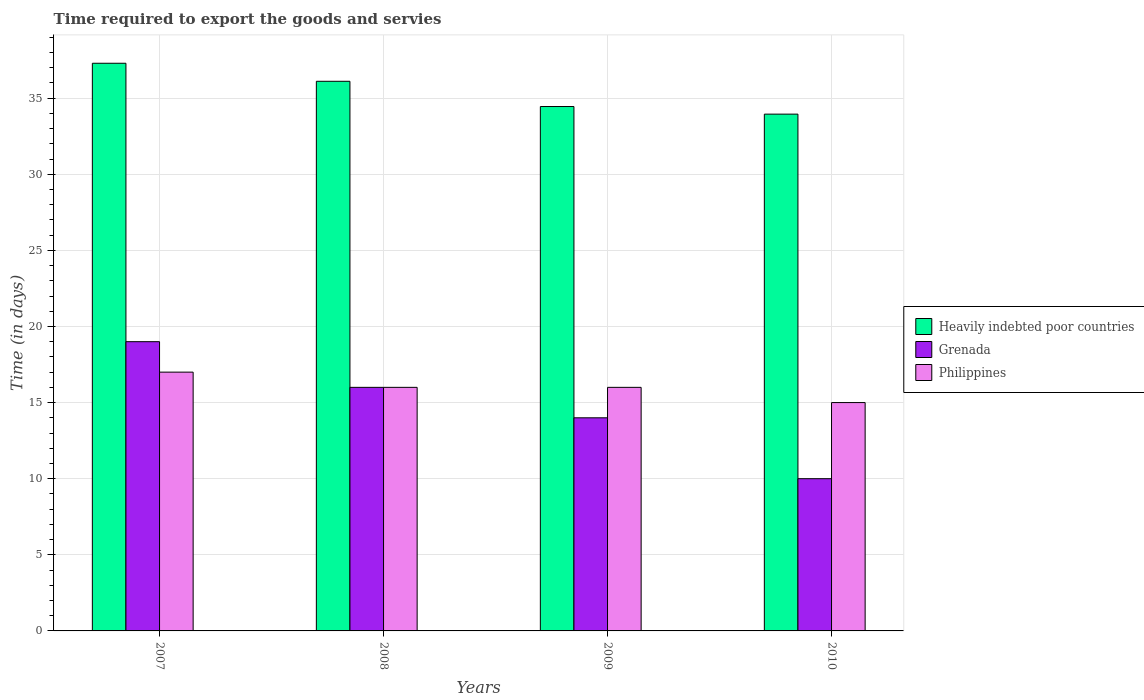Are the number of bars per tick equal to the number of legend labels?
Your answer should be very brief. Yes. Are the number of bars on each tick of the X-axis equal?
Offer a terse response. Yes. How many bars are there on the 3rd tick from the left?
Make the answer very short. 3. How many bars are there on the 1st tick from the right?
Your response must be concise. 3. What is the number of days required to export the goods and services in Grenada in 2009?
Your response must be concise. 14. Across all years, what is the maximum number of days required to export the goods and services in Heavily indebted poor countries?
Keep it short and to the point. 37.29. Across all years, what is the minimum number of days required to export the goods and services in Grenada?
Your answer should be very brief. 10. In which year was the number of days required to export the goods and services in Philippines maximum?
Ensure brevity in your answer.  2007. In which year was the number of days required to export the goods and services in Heavily indebted poor countries minimum?
Ensure brevity in your answer.  2010. What is the total number of days required to export the goods and services in Heavily indebted poor countries in the graph?
Ensure brevity in your answer.  141.79. What is the difference between the number of days required to export the goods and services in Grenada in 2009 and that in 2010?
Your answer should be very brief. 4. What is the difference between the number of days required to export the goods and services in Philippines in 2008 and the number of days required to export the goods and services in Heavily indebted poor countries in 2010?
Your response must be concise. -17.95. What is the average number of days required to export the goods and services in Heavily indebted poor countries per year?
Offer a terse response. 35.45. In the year 2010, what is the difference between the number of days required to export the goods and services in Grenada and number of days required to export the goods and services in Heavily indebted poor countries?
Your answer should be compact. -23.95. In how many years, is the number of days required to export the goods and services in Grenada greater than 10 days?
Provide a succinct answer. 3. Is the number of days required to export the goods and services in Philippines in 2007 less than that in 2009?
Offer a very short reply. No. What is the difference between the highest and the second highest number of days required to export the goods and services in Heavily indebted poor countries?
Provide a short and direct response. 1.18. What is the difference between the highest and the lowest number of days required to export the goods and services in Heavily indebted poor countries?
Make the answer very short. 3.34. In how many years, is the number of days required to export the goods and services in Grenada greater than the average number of days required to export the goods and services in Grenada taken over all years?
Offer a very short reply. 2. What does the 3rd bar from the left in 2007 represents?
Your response must be concise. Philippines. What does the 1st bar from the right in 2007 represents?
Ensure brevity in your answer.  Philippines. Are all the bars in the graph horizontal?
Give a very brief answer. No. How many years are there in the graph?
Provide a short and direct response. 4. What is the difference between two consecutive major ticks on the Y-axis?
Give a very brief answer. 5. Are the values on the major ticks of Y-axis written in scientific E-notation?
Your answer should be compact. No. Does the graph contain any zero values?
Offer a terse response. No. Where does the legend appear in the graph?
Your response must be concise. Center right. How are the legend labels stacked?
Make the answer very short. Vertical. What is the title of the graph?
Give a very brief answer. Time required to export the goods and servies. Does "Palau" appear as one of the legend labels in the graph?
Offer a terse response. No. What is the label or title of the X-axis?
Your answer should be very brief. Years. What is the label or title of the Y-axis?
Your response must be concise. Time (in days). What is the Time (in days) in Heavily indebted poor countries in 2007?
Provide a succinct answer. 37.29. What is the Time (in days) of Philippines in 2007?
Give a very brief answer. 17. What is the Time (in days) of Heavily indebted poor countries in 2008?
Keep it short and to the point. 36.11. What is the Time (in days) of Philippines in 2008?
Keep it short and to the point. 16. What is the Time (in days) in Heavily indebted poor countries in 2009?
Make the answer very short. 34.45. What is the Time (in days) in Grenada in 2009?
Make the answer very short. 14. What is the Time (in days) of Philippines in 2009?
Give a very brief answer. 16. What is the Time (in days) in Heavily indebted poor countries in 2010?
Make the answer very short. 33.95. What is the Time (in days) of Grenada in 2010?
Give a very brief answer. 10. What is the Time (in days) in Philippines in 2010?
Your answer should be compact. 15. Across all years, what is the maximum Time (in days) in Heavily indebted poor countries?
Make the answer very short. 37.29. Across all years, what is the minimum Time (in days) of Heavily indebted poor countries?
Offer a very short reply. 33.95. Across all years, what is the minimum Time (in days) in Grenada?
Offer a very short reply. 10. What is the total Time (in days) in Heavily indebted poor countries in the graph?
Offer a terse response. 141.79. What is the total Time (in days) in Grenada in the graph?
Ensure brevity in your answer.  59. What is the total Time (in days) of Philippines in the graph?
Your response must be concise. 64. What is the difference between the Time (in days) in Heavily indebted poor countries in 2007 and that in 2008?
Make the answer very short. 1.18. What is the difference between the Time (in days) in Philippines in 2007 and that in 2008?
Your answer should be compact. 1. What is the difference between the Time (in days) of Heavily indebted poor countries in 2007 and that in 2009?
Provide a succinct answer. 2.84. What is the difference between the Time (in days) of Philippines in 2007 and that in 2009?
Offer a terse response. 1. What is the difference between the Time (in days) in Heavily indebted poor countries in 2007 and that in 2010?
Give a very brief answer. 3.34. What is the difference between the Time (in days) in Grenada in 2007 and that in 2010?
Make the answer very short. 9. What is the difference between the Time (in days) in Heavily indebted poor countries in 2008 and that in 2009?
Your response must be concise. 1.66. What is the difference between the Time (in days) of Grenada in 2008 and that in 2009?
Keep it short and to the point. 2. What is the difference between the Time (in days) of Philippines in 2008 and that in 2009?
Offer a very short reply. 0. What is the difference between the Time (in days) of Heavily indebted poor countries in 2008 and that in 2010?
Make the answer very short. 2.16. What is the difference between the Time (in days) of Philippines in 2008 and that in 2010?
Your answer should be compact. 1. What is the difference between the Time (in days) in Grenada in 2009 and that in 2010?
Ensure brevity in your answer.  4. What is the difference between the Time (in days) in Philippines in 2009 and that in 2010?
Your answer should be very brief. 1. What is the difference between the Time (in days) of Heavily indebted poor countries in 2007 and the Time (in days) of Grenada in 2008?
Provide a succinct answer. 21.29. What is the difference between the Time (in days) in Heavily indebted poor countries in 2007 and the Time (in days) in Philippines in 2008?
Make the answer very short. 21.29. What is the difference between the Time (in days) in Grenada in 2007 and the Time (in days) in Philippines in 2008?
Give a very brief answer. 3. What is the difference between the Time (in days) in Heavily indebted poor countries in 2007 and the Time (in days) in Grenada in 2009?
Give a very brief answer. 23.29. What is the difference between the Time (in days) of Heavily indebted poor countries in 2007 and the Time (in days) of Philippines in 2009?
Offer a terse response. 21.29. What is the difference between the Time (in days) of Heavily indebted poor countries in 2007 and the Time (in days) of Grenada in 2010?
Your response must be concise. 27.29. What is the difference between the Time (in days) in Heavily indebted poor countries in 2007 and the Time (in days) in Philippines in 2010?
Make the answer very short. 22.29. What is the difference between the Time (in days) of Heavily indebted poor countries in 2008 and the Time (in days) of Grenada in 2009?
Give a very brief answer. 22.11. What is the difference between the Time (in days) in Heavily indebted poor countries in 2008 and the Time (in days) in Philippines in 2009?
Ensure brevity in your answer.  20.11. What is the difference between the Time (in days) in Grenada in 2008 and the Time (in days) in Philippines in 2009?
Provide a succinct answer. 0. What is the difference between the Time (in days) in Heavily indebted poor countries in 2008 and the Time (in days) in Grenada in 2010?
Your answer should be compact. 26.11. What is the difference between the Time (in days) in Heavily indebted poor countries in 2008 and the Time (in days) in Philippines in 2010?
Your response must be concise. 21.11. What is the difference between the Time (in days) of Grenada in 2008 and the Time (in days) of Philippines in 2010?
Offer a terse response. 1. What is the difference between the Time (in days) of Heavily indebted poor countries in 2009 and the Time (in days) of Grenada in 2010?
Provide a succinct answer. 24.45. What is the difference between the Time (in days) in Heavily indebted poor countries in 2009 and the Time (in days) in Philippines in 2010?
Offer a terse response. 19.45. What is the difference between the Time (in days) in Grenada in 2009 and the Time (in days) in Philippines in 2010?
Your response must be concise. -1. What is the average Time (in days) in Heavily indebted poor countries per year?
Your response must be concise. 35.45. What is the average Time (in days) in Grenada per year?
Your answer should be compact. 14.75. In the year 2007, what is the difference between the Time (in days) of Heavily indebted poor countries and Time (in days) of Grenada?
Provide a succinct answer. 18.29. In the year 2007, what is the difference between the Time (in days) of Heavily indebted poor countries and Time (in days) of Philippines?
Make the answer very short. 20.29. In the year 2008, what is the difference between the Time (in days) of Heavily indebted poor countries and Time (in days) of Grenada?
Your answer should be compact. 20.11. In the year 2008, what is the difference between the Time (in days) of Heavily indebted poor countries and Time (in days) of Philippines?
Ensure brevity in your answer.  20.11. In the year 2009, what is the difference between the Time (in days) of Heavily indebted poor countries and Time (in days) of Grenada?
Give a very brief answer. 20.45. In the year 2009, what is the difference between the Time (in days) of Heavily indebted poor countries and Time (in days) of Philippines?
Make the answer very short. 18.45. In the year 2010, what is the difference between the Time (in days) in Heavily indebted poor countries and Time (in days) in Grenada?
Make the answer very short. 23.95. In the year 2010, what is the difference between the Time (in days) of Heavily indebted poor countries and Time (in days) of Philippines?
Provide a succinct answer. 18.95. In the year 2010, what is the difference between the Time (in days) in Grenada and Time (in days) in Philippines?
Your response must be concise. -5. What is the ratio of the Time (in days) in Heavily indebted poor countries in 2007 to that in 2008?
Provide a short and direct response. 1.03. What is the ratio of the Time (in days) in Grenada in 2007 to that in 2008?
Ensure brevity in your answer.  1.19. What is the ratio of the Time (in days) of Philippines in 2007 to that in 2008?
Your answer should be compact. 1.06. What is the ratio of the Time (in days) of Heavily indebted poor countries in 2007 to that in 2009?
Offer a terse response. 1.08. What is the ratio of the Time (in days) in Grenada in 2007 to that in 2009?
Offer a terse response. 1.36. What is the ratio of the Time (in days) in Heavily indebted poor countries in 2007 to that in 2010?
Keep it short and to the point. 1.1. What is the ratio of the Time (in days) of Philippines in 2007 to that in 2010?
Your answer should be very brief. 1.13. What is the ratio of the Time (in days) in Heavily indebted poor countries in 2008 to that in 2009?
Offer a very short reply. 1.05. What is the ratio of the Time (in days) in Heavily indebted poor countries in 2008 to that in 2010?
Provide a succinct answer. 1.06. What is the ratio of the Time (in days) of Philippines in 2008 to that in 2010?
Provide a short and direct response. 1.07. What is the ratio of the Time (in days) of Heavily indebted poor countries in 2009 to that in 2010?
Offer a very short reply. 1.01. What is the ratio of the Time (in days) of Philippines in 2009 to that in 2010?
Your response must be concise. 1.07. What is the difference between the highest and the second highest Time (in days) of Heavily indebted poor countries?
Ensure brevity in your answer.  1.18. What is the difference between the highest and the lowest Time (in days) of Heavily indebted poor countries?
Your answer should be compact. 3.34. 